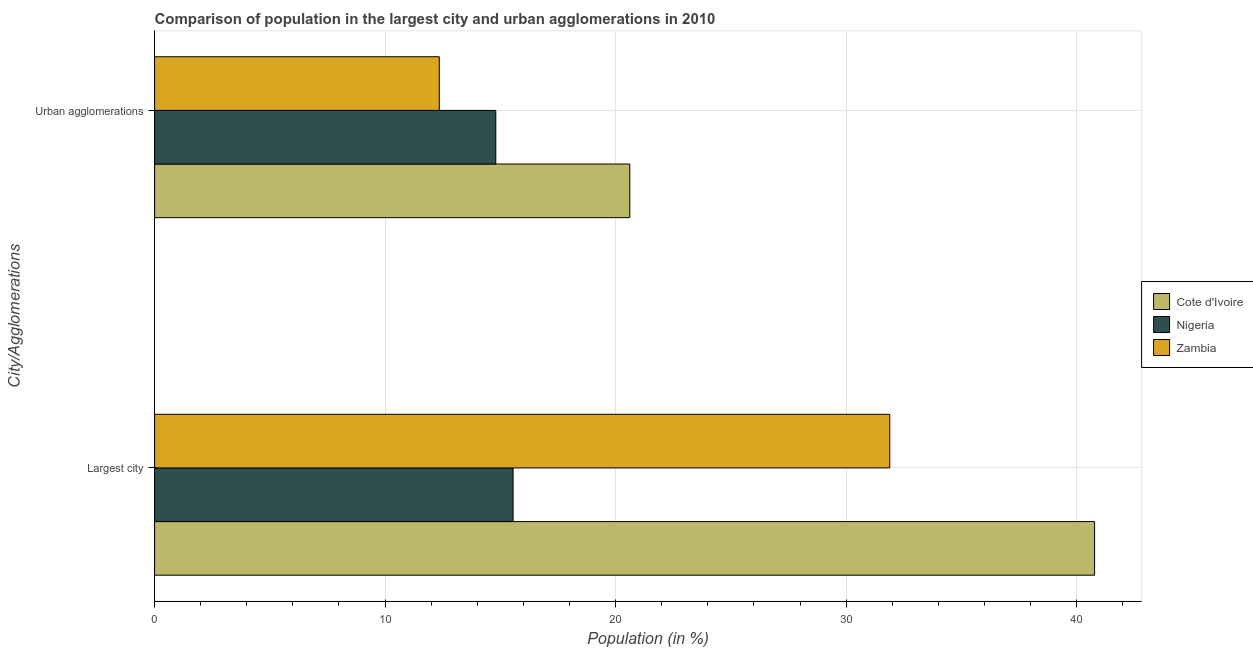How many groups of bars are there?
Offer a very short reply. 2. How many bars are there on the 1st tick from the bottom?
Your response must be concise. 3. What is the label of the 2nd group of bars from the top?
Keep it short and to the point. Largest city. What is the population in urban agglomerations in Cote d'Ivoire?
Offer a very short reply. 20.62. Across all countries, what is the maximum population in urban agglomerations?
Keep it short and to the point. 20.62. Across all countries, what is the minimum population in the largest city?
Your answer should be compact. 15.55. In which country was the population in urban agglomerations maximum?
Your response must be concise. Cote d'Ivoire. In which country was the population in urban agglomerations minimum?
Your response must be concise. Zambia. What is the total population in urban agglomerations in the graph?
Offer a very short reply. 47.77. What is the difference between the population in urban agglomerations in Nigeria and that in Cote d'Ivoire?
Provide a succinct answer. -5.81. What is the difference between the population in urban agglomerations in Cote d'Ivoire and the population in the largest city in Nigeria?
Your response must be concise. 5.06. What is the average population in the largest city per country?
Provide a short and direct response. 29.41. What is the difference between the population in urban agglomerations and population in the largest city in Nigeria?
Your response must be concise. -0.75. What is the ratio of the population in the largest city in Cote d'Ivoire to that in Nigeria?
Your answer should be very brief. 2.62. What does the 2nd bar from the top in Urban agglomerations represents?
Your answer should be compact. Nigeria. What does the 3rd bar from the bottom in Largest city represents?
Your answer should be compact. Zambia. How many bars are there?
Your response must be concise. 6. Are all the bars in the graph horizontal?
Your answer should be compact. Yes. How many countries are there in the graph?
Your response must be concise. 3. Are the values on the major ticks of X-axis written in scientific E-notation?
Ensure brevity in your answer.  No. Does the graph contain any zero values?
Provide a succinct answer. No. Does the graph contain grids?
Offer a terse response. Yes. How many legend labels are there?
Provide a succinct answer. 3. What is the title of the graph?
Provide a short and direct response. Comparison of population in the largest city and urban agglomerations in 2010. Does "Philippines" appear as one of the legend labels in the graph?
Ensure brevity in your answer.  No. What is the label or title of the X-axis?
Your response must be concise. Population (in %). What is the label or title of the Y-axis?
Keep it short and to the point. City/Agglomerations. What is the Population (in %) in Cote d'Ivoire in Largest city?
Your answer should be compact. 40.78. What is the Population (in %) of Nigeria in Largest city?
Your response must be concise. 15.55. What is the Population (in %) of Zambia in Largest city?
Keep it short and to the point. 31.89. What is the Population (in %) in Cote d'Ivoire in Urban agglomerations?
Give a very brief answer. 20.62. What is the Population (in %) of Nigeria in Urban agglomerations?
Your response must be concise. 14.8. What is the Population (in %) of Zambia in Urban agglomerations?
Offer a terse response. 12.35. Across all City/Agglomerations, what is the maximum Population (in %) in Cote d'Ivoire?
Your answer should be compact. 40.78. Across all City/Agglomerations, what is the maximum Population (in %) of Nigeria?
Ensure brevity in your answer.  15.55. Across all City/Agglomerations, what is the maximum Population (in %) in Zambia?
Offer a terse response. 31.89. Across all City/Agglomerations, what is the minimum Population (in %) of Cote d'Ivoire?
Provide a short and direct response. 20.62. Across all City/Agglomerations, what is the minimum Population (in %) of Nigeria?
Provide a short and direct response. 14.8. Across all City/Agglomerations, what is the minimum Population (in %) of Zambia?
Provide a short and direct response. 12.35. What is the total Population (in %) of Cote d'Ivoire in the graph?
Ensure brevity in your answer.  61.39. What is the total Population (in %) of Nigeria in the graph?
Your response must be concise. 30.36. What is the total Population (in %) in Zambia in the graph?
Keep it short and to the point. 44.24. What is the difference between the Population (in %) of Cote d'Ivoire in Largest city and that in Urban agglomerations?
Make the answer very short. 20.16. What is the difference between the Population (in %) in Nigeria in Largest city and that in Urban agglomerations?
Give a very brief answer. 0.75. What is the difference between the Population (in %) of Zambia in Largest city and that in Urban agglomerations?
Offer a terse response. 19.54. What is the difference between the Population (in %) of Cote d'Ivoire in Largest city and the Population (in %) of Nigeria in Urban agglomerations?
Offer a very short reply. 25.97. What is the difference between the Population (in %) in Cote d'Ivoire in Largest city and the Population (in %) in Zambia in Urban agglomerations?
Give a very brief answer. 28.43. What is the difference between the Population (in %) in Nigeria in Largest city and the Population (in %) in Zambia in Urban agglomerations?
Ensure brevity in your answer.  3.2. What is the average Population (in %) of Cote d'Ivoire per City/Agglomerations?
Your response must be concise. 30.7. What is the average Population (in %) of Nigeria per City/Agglomerations?
Keep it short and to the point. 15.18. What is the average Population (in %) of Zambia per City/Agglomerations?
Provide a short and direct response. 22.12. What is the difference between the Population (in %) in Cote d'Ivoire and Population (in %) in Nigeria in Largest city?
Keep it short and to the point. 25.22. What is the difference between the Population (in %) in Cote d'Ivoire and Population (in %) in Zambia in Largest city?
Your response must be concise. 8.88. What is the difference between the Population (in %) in Nigeria and Population (in %) in Zambia in Largest city?
Offer a very short reply. -16.34. What is the difference between the Population (in %) of Cote d'Ivoire and Population (in %) of Nigeria in Urban agglomerations?
Provide a succinct answer. 5.81. What is the difference between the Population (in %) of Cote d'Ivoire and Population (in %) of Zambia in Urban agglomerations?
Ensure brevity in your answer.  8.27. What is the difference between the Population (in %) in Nigeria and Population (in %) in Zambia in Urban agglomerations?
Offer a terse response. 2.45. What is the ratio of the Population (in %) in Cote d'Ivoire in Largest city to that in Urban agglomerations?
Your answer should be very brief. 1.98. What is the ratio of the Population (in %) of Nigeria in Largest city to that in Urban agglomerations?
Offer a terse response. 1.05. What is the ratio of the Population (in %) of Zambia in Largest city to that in Urban agglomerations?
Make the answer very short. 2.58. What is the difference between the highest and the second highest Population (in %) in Cote d'Ivoire?
Your answer should be very brief. 20.16. What is the difference between the highest and the second highest Population (in %) in Nigeria?
Make the answer very short. 0.75. What is the difference between the highest and the second highest Population (in %) of Zambia?
Ensure brevity in your answer.  19.54. What is the difference between the highest and the lowest Population (in %) of Cote d'Ivoire?
Your answer should be very brief. 20.16. What is the difference between the highest and the lowest Population (in %) in Nigeria?
Your answer should be very brief. 0.75. What is the difference between the highest and the lowest Population (in %) of Zambia?
Your answer should be very brief. 19.54. 